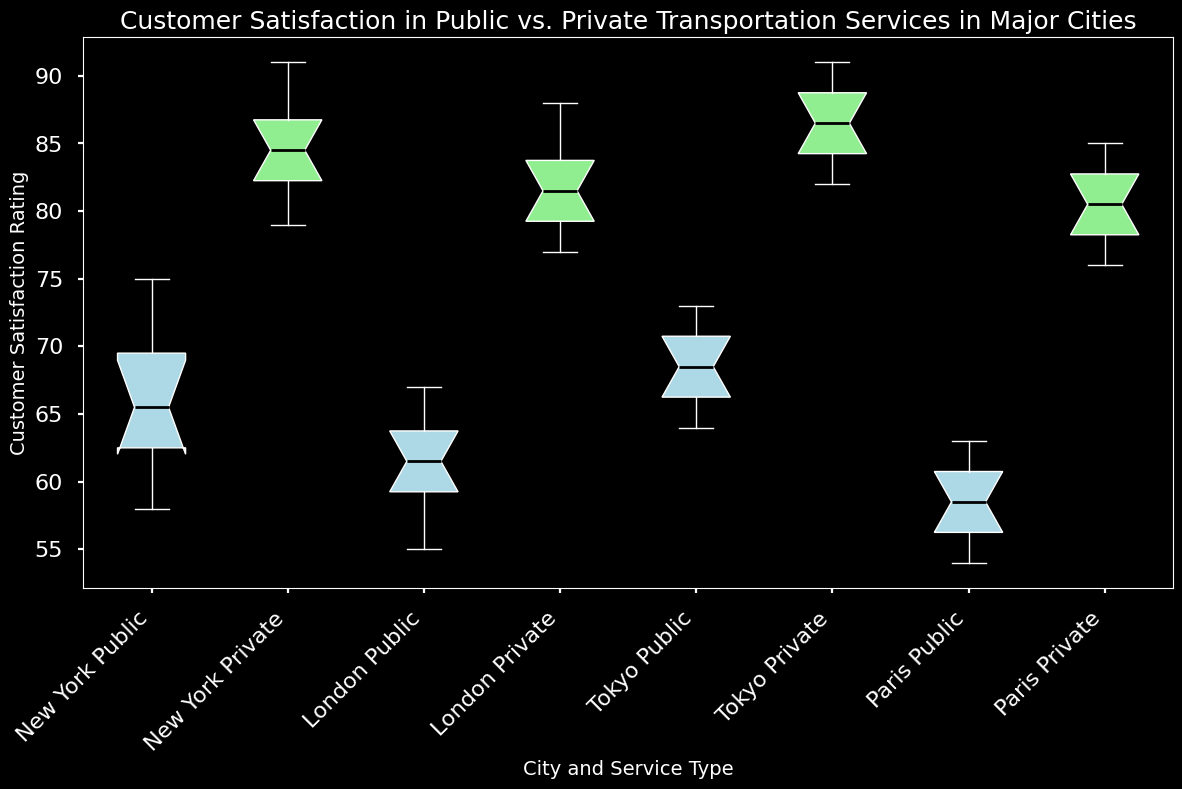What is the median customer satisfaction rating for public transportation services in New York? To find the median, locate the middle value in the sorted list of customer satisfaction ratings for public transportation in New York: [58, 60, 62, 64, 65, 66, 68, 70, 72, 75]. The median is the average of the 5th and 6th values, (65 + 66)/2 = 65.5
Answer: 65.5 Which city has the highest median customer satisfaction rating for private transportation services? Look at the medians of customer satisfaction ratings for private transportation services in each city. New York's median is 84, London's is 81.5, Tokyo's is 87, and Paris's is 81. Therefore, Tokyo has the highest median rating.
Answer: Tokyo Are the medians of customer satisfaction ratings for private transportation services higher than public ones in all cities? Compare the median ratings for both public and private transportation services in each city: New York, London, Tokyo, and Paris. In all cities, the median for private services is higher than that for public services.
Answer: Yes What's the interquartile range (IQR) of customer satisfaction ratings for public transportation in Tokyo? The IQR is the range between the first quartile (Q1) and third quartile (Q3). For Tokyo's public transportation, Q1 (25th percentile) is 66, and Q3 (75th percentile) is 71. The IQR is 71 - 66 = 5
Answer: 5 Which city shows the largest difference in median customer satisfaction rating between public and private transportation services? Find the difference in medians for each city: New York (84 - 65.5 = 18.5), London (81.5 - 61.5 = 20), Tokyo (87 - 68.5 = 18.5), Paris (81 - 58.5 = 22.5). Paris shows the largest difference.
Answer: Paris Is the spread of customer satisfaction ratings larger for private transportation or public transportation in New York? Compare the range (max - min) of customer satisfaction scores: Public (75 - 58 = 17) and Private (91 - 79 = 12). The spread is larger for public transportation.
Answer: Public transportation For which city is the median for public transportation customer satisfaction closest to the median for private transportation customer satisfaction in New York? Compare the median of public transportation in each city with the median of private transportation in New York (84): New York's public (65.5), London's public (61.5), Tokyo's public (68.5), Paris's public (58.5). Tokyo's public median (68.5) is closest to 84.
Answer: Tokyo 